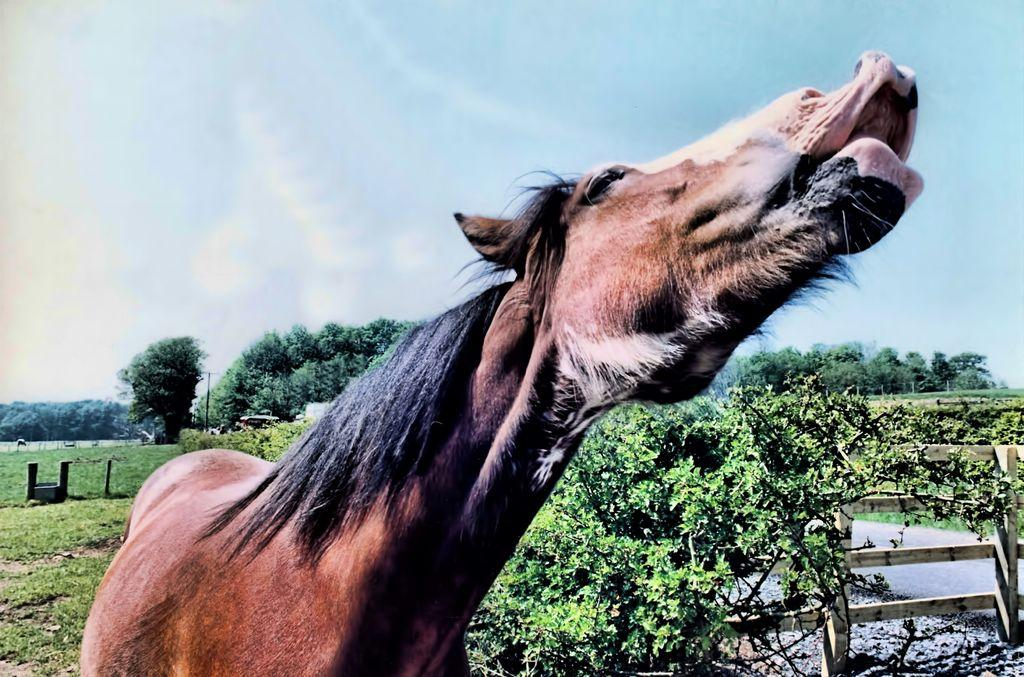What type of animal is in the image? There is an animal in the image, but the specific type cannot be determined from the provided facts. What is separating the animal from the rest of the image? There is a fence in the image that separates the animal from the rest of the image. What can be seen in the foreground of the image? Water is visible in the foreground of the image. What is present on the ground in the image? There are objects on the ground in the image. What can be seen in the background of the image? There are trees and the sky visible in the background of the image. What type of pear is being used to tickle the animal in the image? There is no pear present in the image, nor is there any indication that the animal is being tickled. 